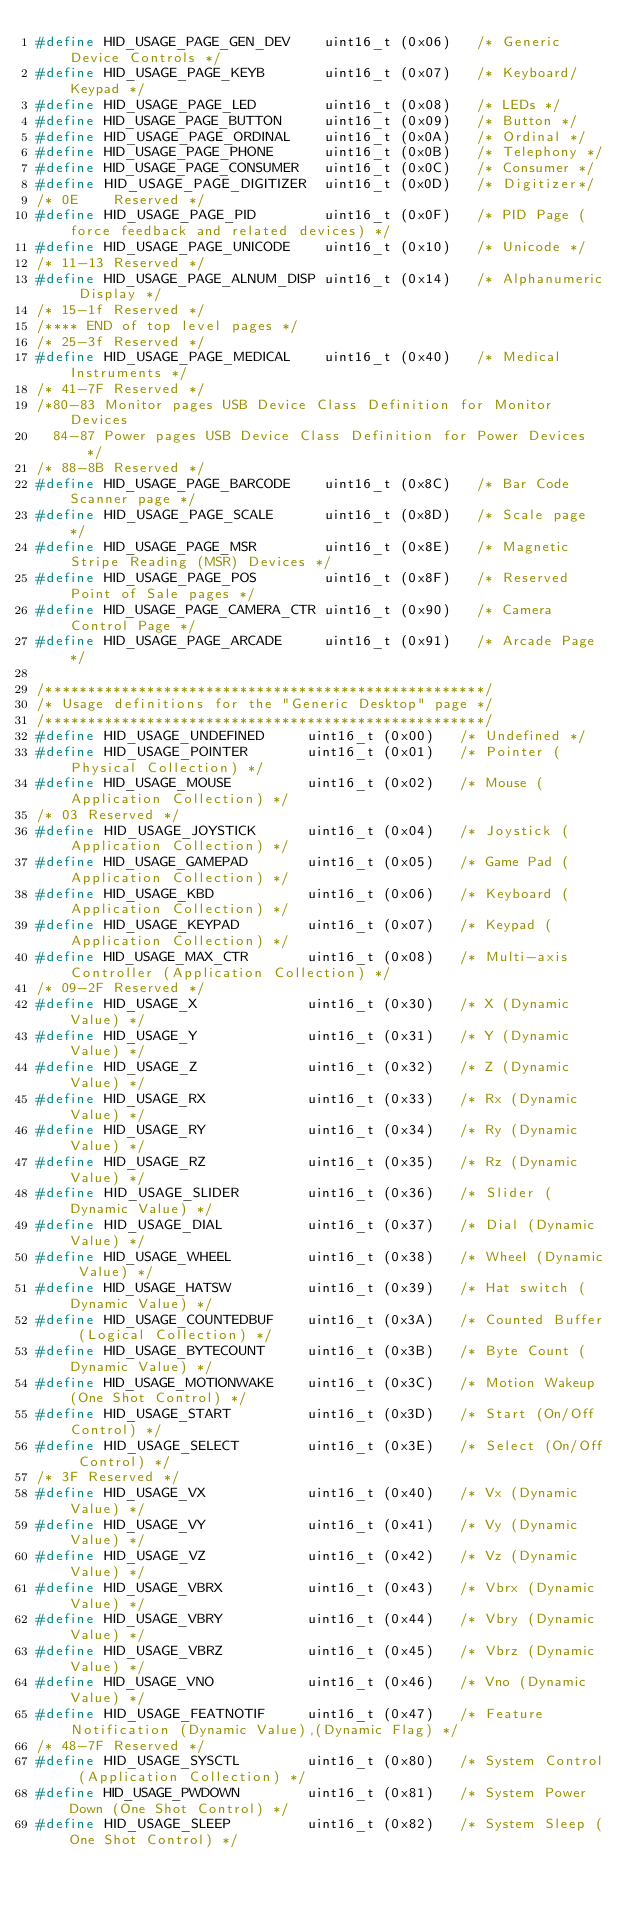Convert code to text. <code><loc_0><loc_0><loc_500><loc_500><_C_>#define HID_USAGE_PAGE_GEN_DEV    uint16_t (0x06)   /* Generic Device Controls */
#define HID_USAGE_PAGE_KEYB       uint16_t (0x07)   /* Keyboard/Keypad */
#define HID_USAGE_PAGE_LED        uint16_t (0x08)   /* LEDs */
#define HID_USAGE_PAGE_BUTTON     uint16_t (0x09)   /* Button */
#define HID_USAGE_PAGE_ORDINAL    uint16_t (0x0A)   /* Ordinal */
#define HID_USAGE_PAGE_PHONE      uint16_t (0x0B)   /* Telephony */
#define HID_USAGE_PAGE_CONSUMER   uint16_t (0x0C)   /* Consumer */
#define HID_USAGE_PAGE_DIGITIZER  uint16_t (0x0D)   /* Digitizer*/
/* 0E    Reserved */
#define HID_USAGE_PAGE_PID        uint16_t (0x0F)   /* PID Page (force feedback and related devices) */
#define HID_USAGE_PAGE_UNICODE    uint16_t (0x10)   /* Unicode */
/* 11-13 Reserved */
#define HID_USAGE_PAGE_ALNUM_DISP uint16_t (0x14)   /* Alphanumeric Display */
/* 15-1f Reserved */
/**** END of top level pages */
/* 25-3f Reserved */
#define HID_USAGE_PAGE_MEDICAL    uint16_t (0x40)   /* Medical Instruments */
/* 41-7F Reserved */
/*80-83 Monitor pages USB Device Class Definition for Monitor Devices
  84-87 Power pages USB Device Class Definition for Power Devices */
/* 88-8B Reserved */
#define HID_USAGE_PAGE_BARCODE    uint16_t (0x8C)   /* Bar Code Scanner page */
#define HID_USAGE_PAGE_SCALE      uint16_t (0x8D)   /* Scale page */
#define HID_USAGE_PAGE_MSR        uint16_t (0x8E)   /* Magnetic Stripe Reading (MSR) Devices */
#define HID_USAGE_PAGE_POS        uint16_t (0x8F)   /* Reserved Point of Sale pages */
#define HID_USAGE_PAGE_CAMERA_CTR uint16_t (0x90)   /* Camera Control Page */
#define HID_USAGE_PAGE_ARCADE     uint16_t (0x91)   /* Arcade Page */

/****************************************************/
/* Usage definitions for the "Generic Desktop" page */
/****************************************************/
#define HID_USAGE_UNDEFINED     uint16_t (0x00)   /* Undefined */
#define HID_USAGE_POINTER       uint16_t (0x01)   /* Pointer (Physical Collection) */
#define HID_USAGE_MOUSE         uint16_t (0x02)   /* Mouse (Application Collection) */
/* 03 Reserved */
#define HID_USAGE_JOYSTICK      uint16_t (0x04)   /* Joystick (Application Collection) */
#define HID_USAGE_GAMEPAD       uint16_t (0x05)   /* Game Pad (Application Collection) */
#define HID_USAGE_KBD           uint16_t (0x06)   /* Keyboard (Application Collection) */
#define HID_USAGE_KEYPAD        uint16_t (0x07)   /* Keypad (Application Collection) */
#define HID_USAGE_MAX_CTR       uint16_t (0x08)   /* Multi-axis Controller (Application Collection) */
/* 09-2F Reserved */
#define HID_USAGE_X             uint16_t (0x30)   /* X (Dynamic Value) */
#define HID_USAGE_Y             uint16_t (0x31)   /* Y (Dynamic Value) */
#define HID_USAGE_Z             uint16_t (0x32)   /* Z (Dynamic Value) */
#define HID_USAGE_RX            uint16_t (0x33)   /* Rx (Dynamic Value) */
#define HID_USAGE_RY            uint16_t (0x34)   /* Ry (Dynamic Value) */
#define HID_USAGE_RZ            uint16_t (0x35)   /* Rz (Dynamic Value) */
#define HID_USAGE_SLIDER        uint16_t (0x36)   /* Slider (Dynamic Value) */
#define HID_USAGE_DIAL          uint16_t (0x37)   /* Dial (Dynamic Value) */
#define HID_USAGE_WHEEL         uint16_t (0x38)   /* Wheel (Dynamic Value) */
#define HID_USAGE_HATSW         uint16_t (0x39)   /* Hat switch (Dynamic Value) */
#define HID_USAGE_COUNTEDBUF    uint16_t (0x3A)   /* Counted Buffer (Logical Collection) */
#define HID_USAGE_BYTECOUNT     uint16_t (0x3B)   /* Byte Count (Dynamic Value) */
#define HID_USAGE_MOTIONWAKE    uint16_t (0x3C)   /* Motion Wakeup (One Shot Control) */
#define HID_USAGE_START         uint16_t (0x3D)   /* Start (On/Off Control) */
#define HID_USAGE_SELECT        uint16_t (0x3E)   /* Select (On/Off Control) */
/* 3F Reserved */
#define HID_USAGE_VX            uint16_t (0x40)   /* Vx (Dynamic Value) */
#define HID_USAGE_VY            uint16_t (0x41)   /* Vy (Dynamic Value) */
#define HID_USAGE_VZ            uint16_t (0x42)   /* Vz (Dynamic Value) */
#define HID_USAGE_VBRX          uint16_t (0x43)   /* Vbrx (Dynamic Value) */
#define HID_USAGE_VBRY          uint16_t (0x44)   /* Vbry (Dynamic Value) */
#define HID_USAGE_VBRZ          uint16_t (0x45)   /* Vbrz (Dynamic Value) */
#define HID_USAGE_VNO           uint16_t (0x46)   /* Vno (Dynamic Value) */
#define HID_USAGE_FEATNOTIF     uint16_t (0x47)   /* Feature Notification (Dynamic Value),(Dynamic Flag) */
/* 48-7F Reserved */
#define HID_USAGE_SYSCTL        uint16_t (0x80)   /* System Control (Application Collection) */
#define HID_USAGE_PWDOWN        uint16_t (0x81)   /* System Power Down (One Shot Control) */
#define HID_USAGE_SLEEP         uint16_t (0x82)   /* System Sleep (One Shot Control) */</code> 